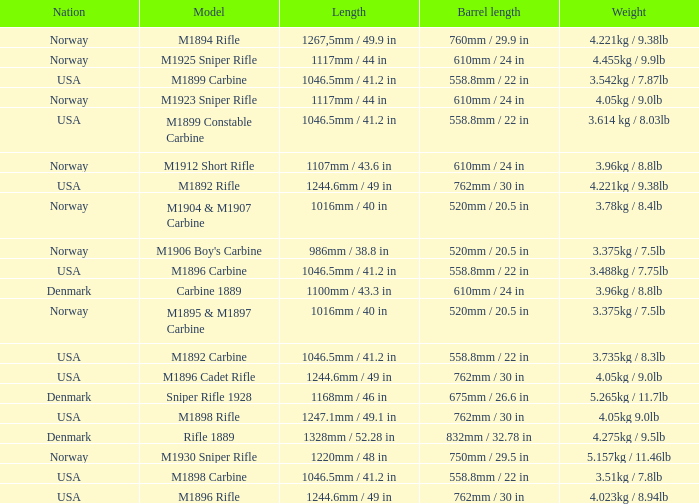What is Length, when Barrel Length is 750mm / 29.5 in? 1220mm / 48 in. 